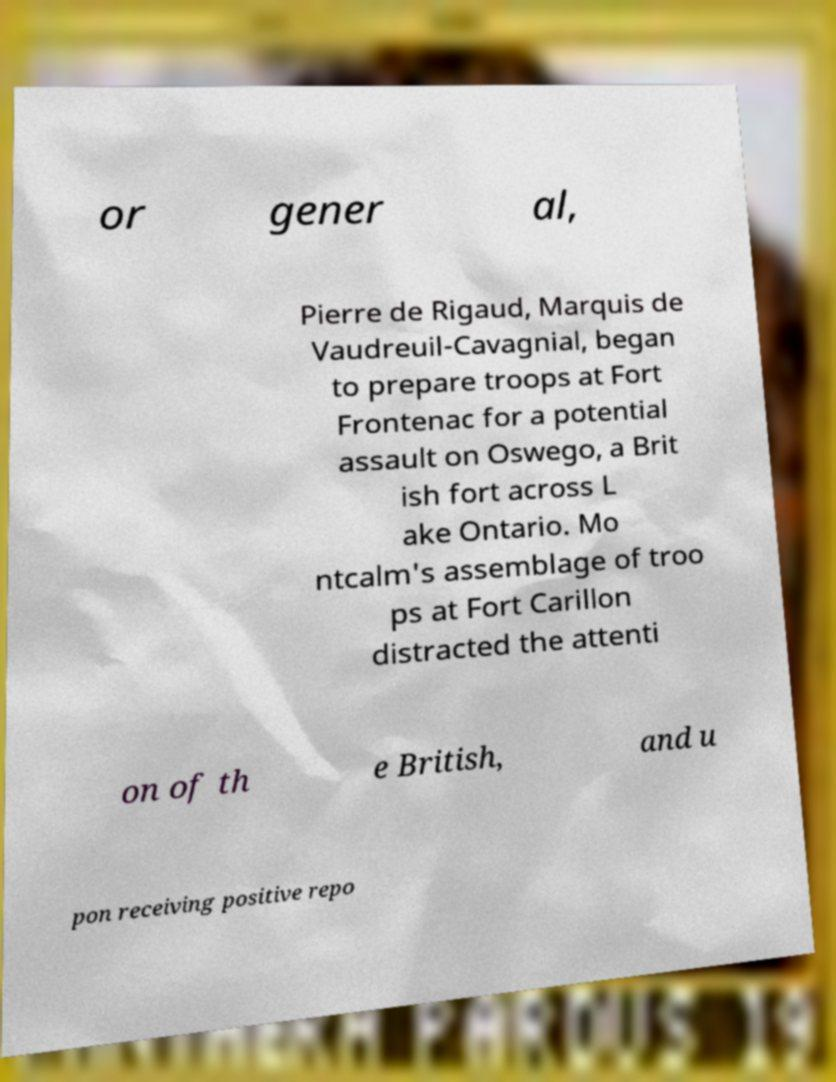There's text embedded in this image that I need extracted. Can you transcribe it verbatim? or gener al, Pierre de Rigaud, Marquis de Vaudreuil-Cavagnial, began to prepare troops at Fort Frontenac for a potential assault on Oswego, a Brit ish fort across L ake Ontario. Mo ntcalm's assemblage of troo ps at Fort Carillon distracted the attenti on of th e British, and u pon receiving positive repo 